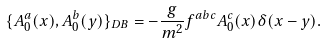Convert formula to latex. <formula><loc_0><loc_0><loc_500><loc_500>\{ A _ { 0 } ^ { a } ( x ) , A _ { 0 } ^ { b } ( y ) \} _ { D B } = - \frac { g } { m ^ { 2 } } f ^ { a b c } A _ { 0 } ^ { c } ( x ) \delta ( x - y ) .</formula> 